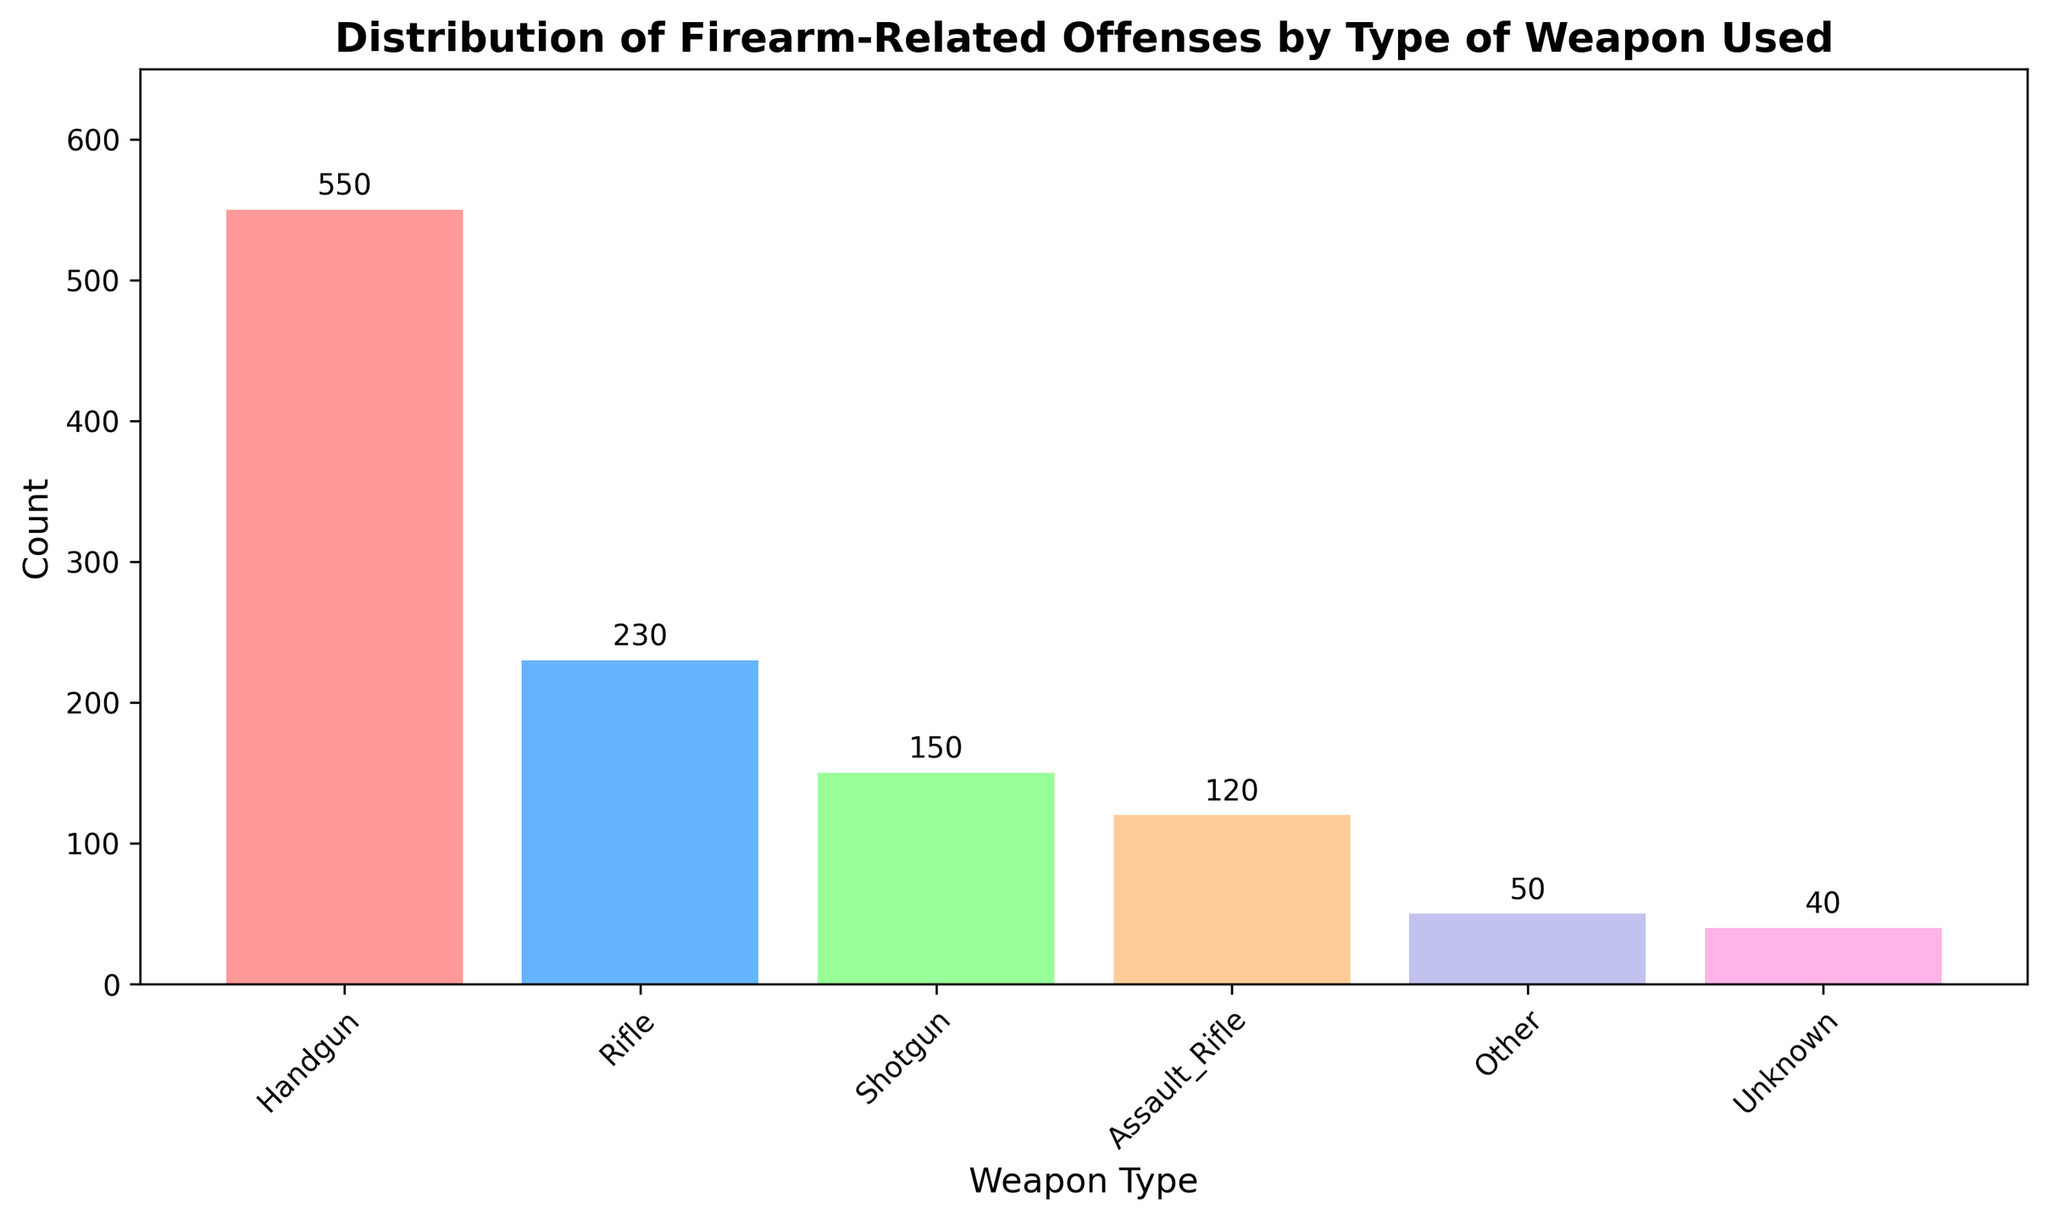What type of weapon is used most frequently in firearm-related offenses? By looking at the height of the bars, the bar for "Handgun" is the tallest one. This suggests it has the highest count compared to other weapon types.
Answer: Handgun Which weapon type is used least frequently in firearm-related offenses? The shortest bar on the histogram represents the weapon type "Unknown," which indicates it has the lowest count among all the weapon types listed.
Answer: Unknown How many more offenses involved handguns compared to rifles? The count for Handguns is 550, and the count for Rifles is 230. Subtract the number of offenses involving Rifles from those involving Handguns: 550 - 230 = 320.
Answer: 320 What is the total number of firearm-related offenses reported in the figure? Add the counts for all weapon types: 550 (Handgun) + 230 (Rifle) + 150 (Shotgun) + 120 (Assault_Rifle) + 50 (Other) + 40 (Unknown) = 1140.
Answer: 1140 Are shotguns used more frequently or less frequently than assault rifles in firearm-related offenses? By comparing the heights of their respective bars, the bar for Shotgun is taller than the bar for Assault_Rifle, indicating a higher count for Shotguns.
Answer: More frequently What is the percentage of offenses involving handguns out of the total offenses? First, calculate the total number of offenses, which is 1140. Then, divide the number of handgun offenses by the total and multiply by 100 to get the percentage: (550 / 1140) * 100 ≈ 48.25%.
Answer: 48.25% What is the combined count of offenses involving shotguns and assault rifles? Sum the counts for Shotguns and Assault_Rifles: 150 (Shotgun) + 120 (Assault_Rifle) = 270.
Answer: 270 How does the count for "Other" compare to the count for "Unknown"? Looking at the heights of the bars, "Other" has a count of 50 while "Unknown" has a count of 40, meaning "Other" is greater by 10.
Answer: Other is greater by 10 What's the difference in offenses between the weapon type with the highest count and the weapon type with the lowest count? Subtract the count for the lowest weapon type (Unknown: 40) from the count for the highest weapon type (Handgun: 550): 550 - 40 = 510.
Answer: 510 